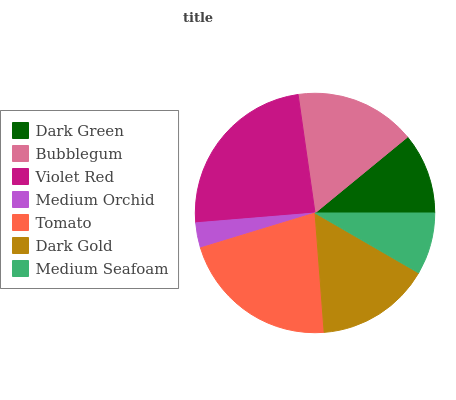Is Medium Orchid the minimum?
Answer yes or no. Yes. Is Violet Red the maximum?
Answer yes or no. Yes. Is Bubblegum the minimum?
Answer yes or no. No. Is Bubblegum the maximum?
Answer yes or no. No. Is Bubblegum greater than Dark Green?
Answer yes or no. Yes. Is Dark Green less than Bubblegum?
Answer yes or no. Yes. Is Dark Green greater than Bubblegum?
Answer yes or no. No. Is Bubblegum less than Dark Green?
Answer yes or no. No. Is Dark Gold the high median?
Answer yes or no. Yes. Is Dark Gold the low median?
Answer yes or no. Yes. Is Medium Orchid the high median?
Answer yes or no. No. Is Medium Seafoam the low median?
Answer yes or no. No. 